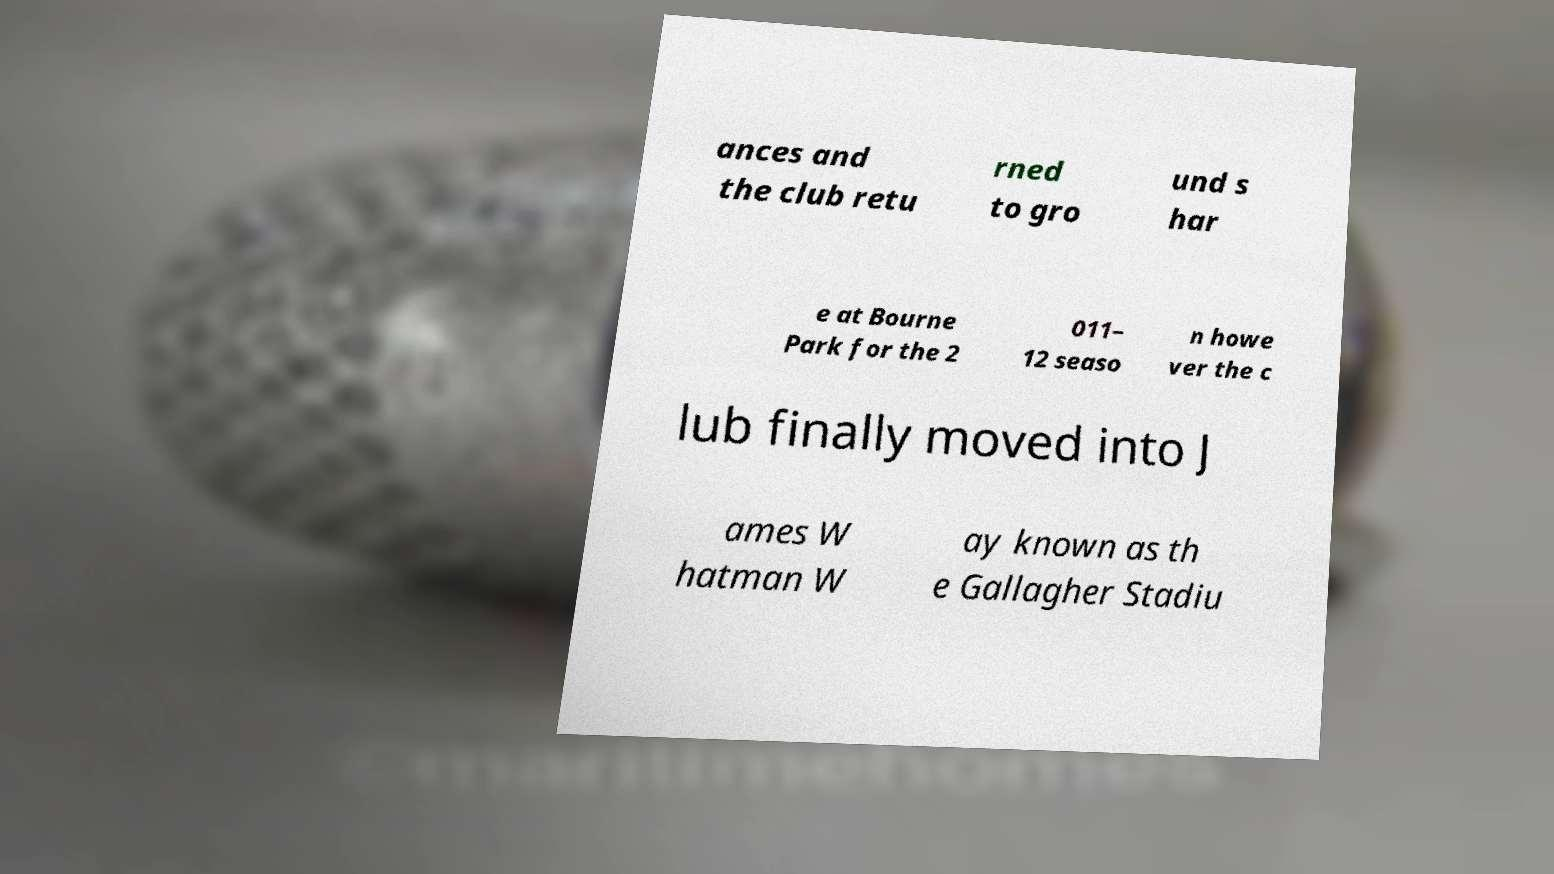For documentation purposes, I need the text within this image transcribed. Could you provide that? ances and the club retu rned to gro und s har e at Bourne Park for the 2 011– 12 seaso n howe ver the c lub finally moved into J ames W hatman W ay known as th e Gallagher Stadiu 